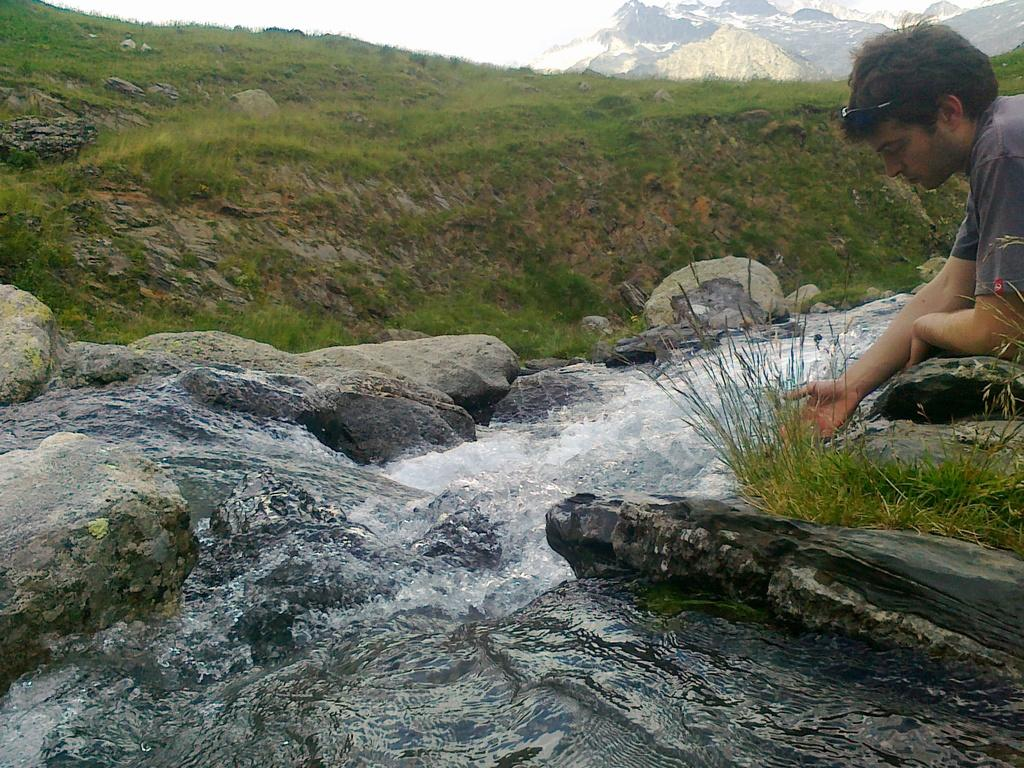Who is on the right side of the image? There is a man on the right side of the image. What can be seen in the image besides the man? Water and rocks are present in the image. What type of vegetation is visible in the background of the image? There is grass visible in the background of the image. Where is the kitty hiding with the bomb in the image? There is no kitty or bomb present in the image. 